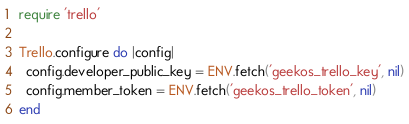<code> <loc_0><loc_0><loc_500><loc_500><_Ruby_>require 'trello'

Trello.configure do |config|
  config.developer_public_key = ENV.fetch('geekos_trello_key', nil)
  config.member_token = ENV.fetch('geekos_trello_token', nil)
end
</code> 